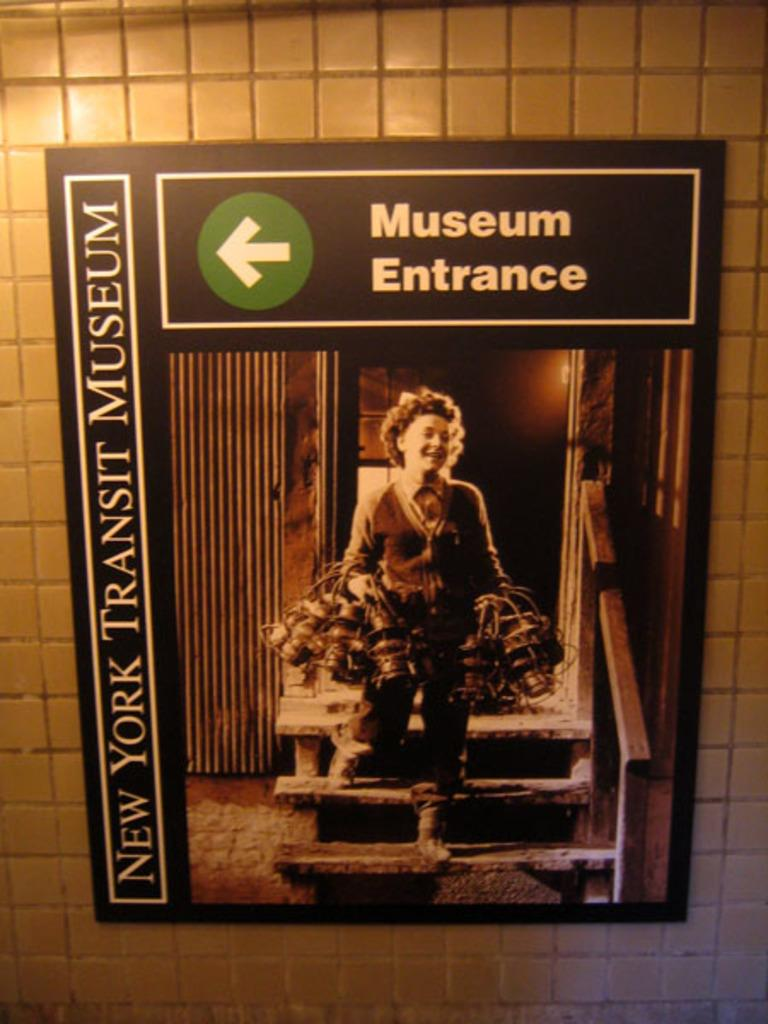<image>
Summarize the visual content of the image. A sign on a white tile wall indicating the direction of the entrance to the New York Transit Museum. 